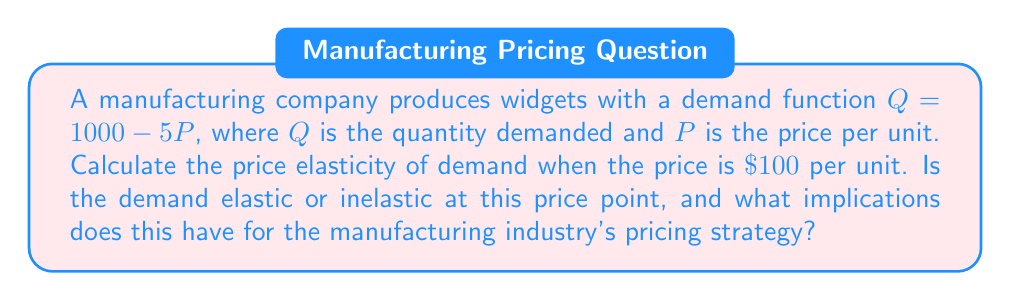Help me with this question. To solve this problem, we'll follow these steps:

1) The formula for price elasticity of demand is:

   $$E_d = \left|\frac{\% \text{ change in quantity}}{\% \text{ change in price}}\right| = \left|\frac{dQ}{dP} \cdot \frac{P}{Q}\right|$$

2) First, we need to find $\frac{dQ}{dP}$. From the demand function $Q = 1000 - 5P$, we can see that $\frac{dQ}{dP} = -5$.

3) Next, we need to find $Q$ when $P = 100$:
   
   $Q = 1000 - 5(100) = 1000 - 500 = 500$

4) Now we can substitute these values into the elasticity formula:

   $$E_d = \left|-5 \cdot \frac{100}{500}\right| = \left|-1\right| = 1$$

5) Interpreting the result:
   - If $E_d > 1$, demand is elastic
   - If $E_d < 1$, demand is inelastic
   - If $E_d = 1$, demand is unit elastic

   In this case, $E_d = 1$, so demand is unit elastic at $P = \$100$.

6) Implications for the manufacturing industry:
   At this price point, a change in price will result in a proportional change in quantity demanded. This means that total revenue will remain constant regardless of small price changes. The industry might consider this a stable pricing point, but there's no clear advantage to either raising or lowering prices in terms of total revenue.
Answer: $E_d = 1$; unit elastic. Pricing changes won't affect total revenue. 